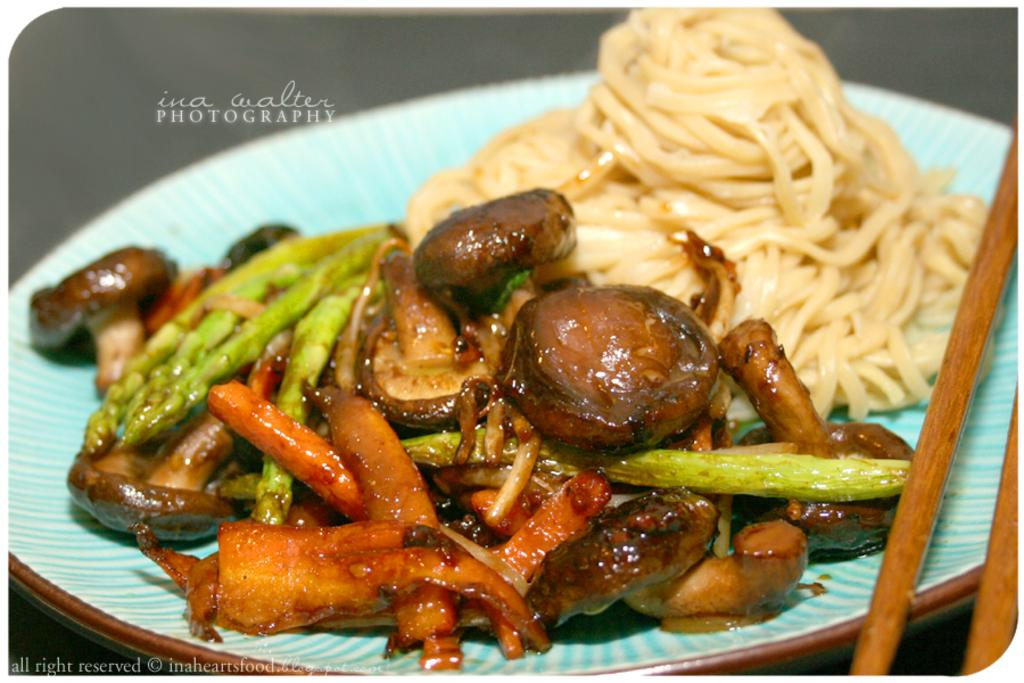What is on the plate that is visible in the image? There is food on the plate in the image. What utensils are present in the image? Chopsticks are present in the image. What territory does the fireman claim in the image? There is no fireman present in the image, so no territory can be claimed. 